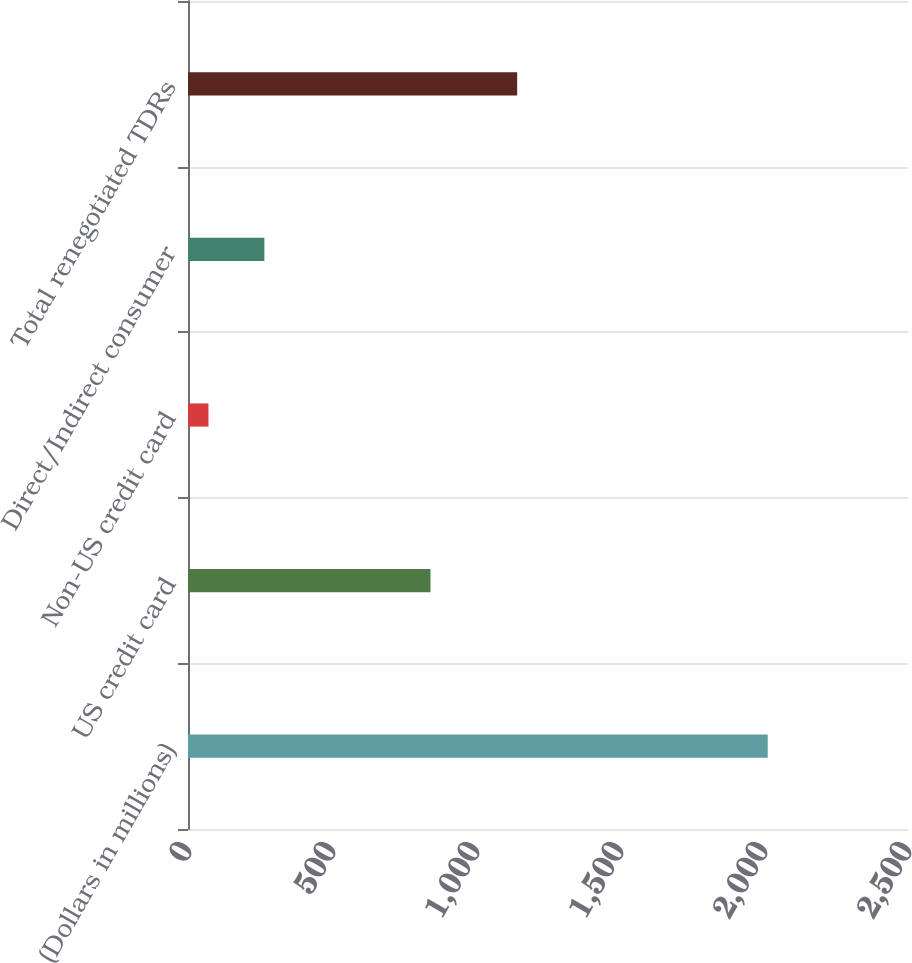Convert chart. <chart><loc_0><loc_0><loc_500><loc_500><bar_chart><fcel>(Dollars in millions)<fcel>US credit card<fcel>Non-US credit card<fcel>Direct/Indirect consumer<fcel>Total renegotiated TDRs<nl><fcel>2013<fcel>842<fcel>71<fcel>265.2<fcel>1143<nl></chart> 